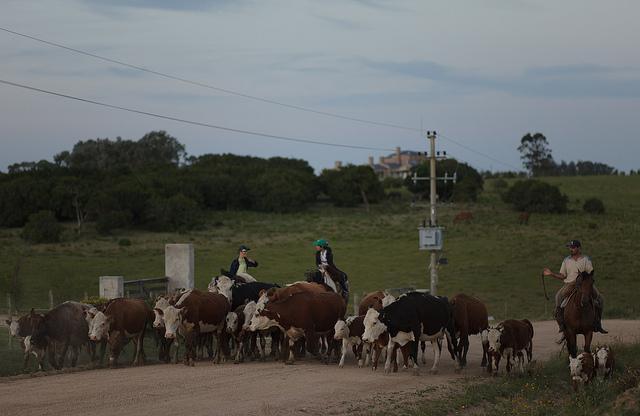How many cows are visible?
Give a very brief answer. 7. 